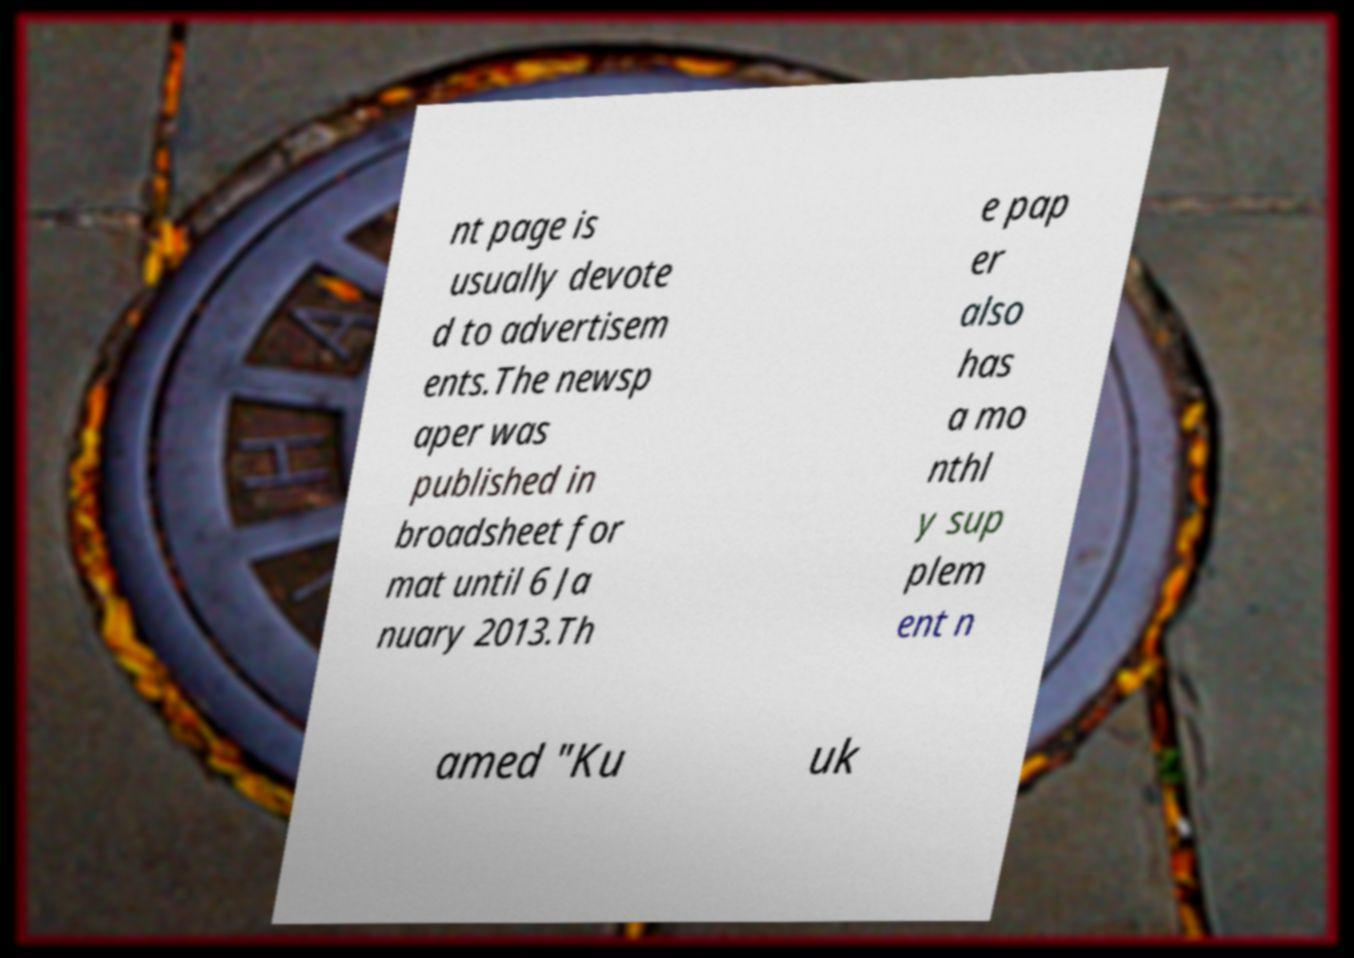There's text embedded in this image that I need extracted. Can you transcribe it verbatim? nt page is usually devote d to advertisem ents.The newsp aper was published in broadsheet for mat until 6 Ja nuary 2013.Th e pap er also has a mo nthl y sup plem ent n amed "Ku uk 